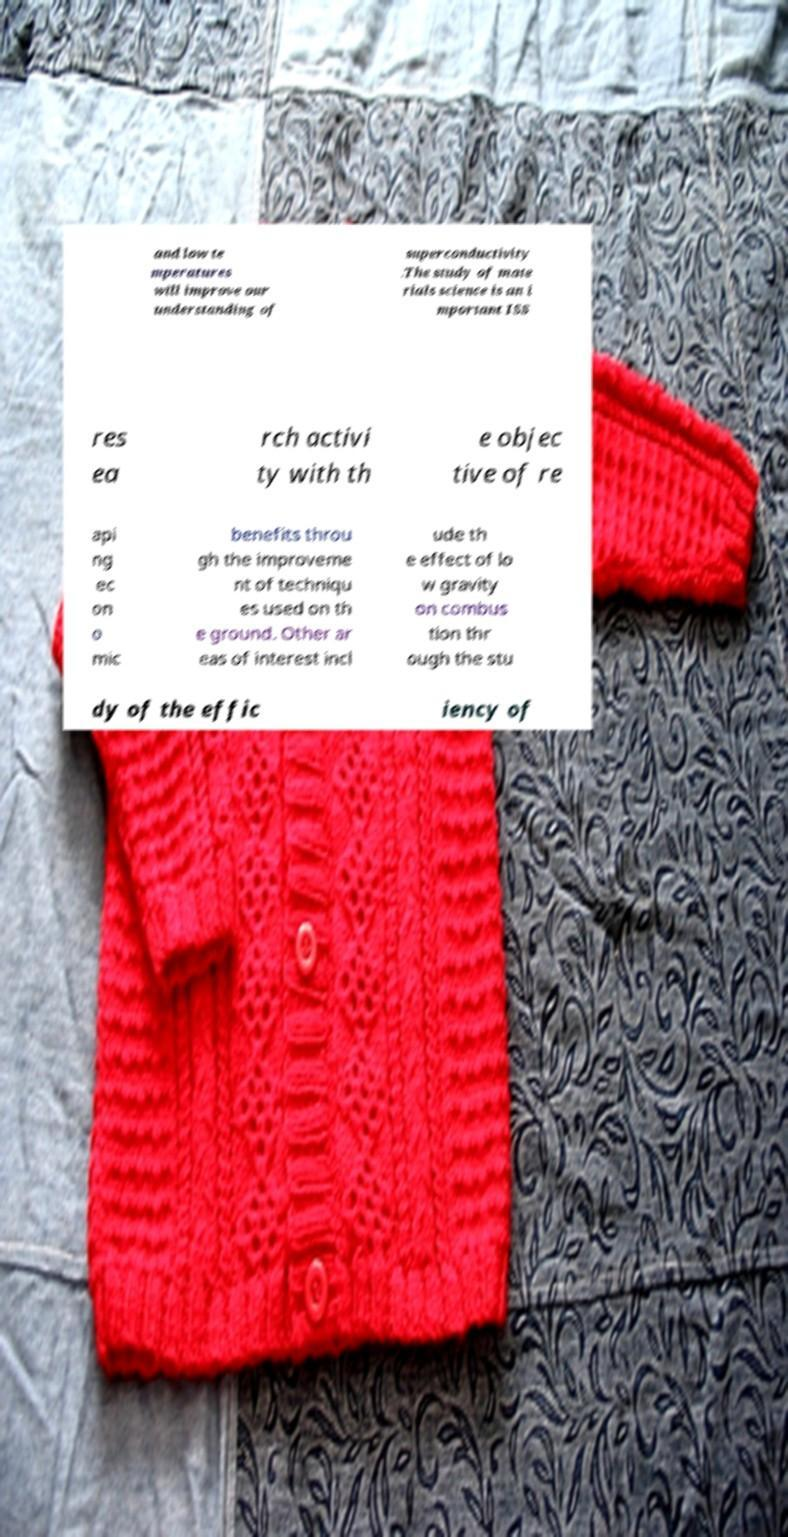I need the written content from this picture converted into text. Can you do that? and low te mperatures will improve our understanding of superconductivity .The study of mate rials science is an i mportant ISS res ea rch activi ty with th e objec tive of re api ng ec on o mic benefits throu gh the improveme nt of techniqu es used on th e ground. Other ar eas of interest incl ude th e effect of lo w gravity on combus tion thr ough the stu dy of the effic iency of 